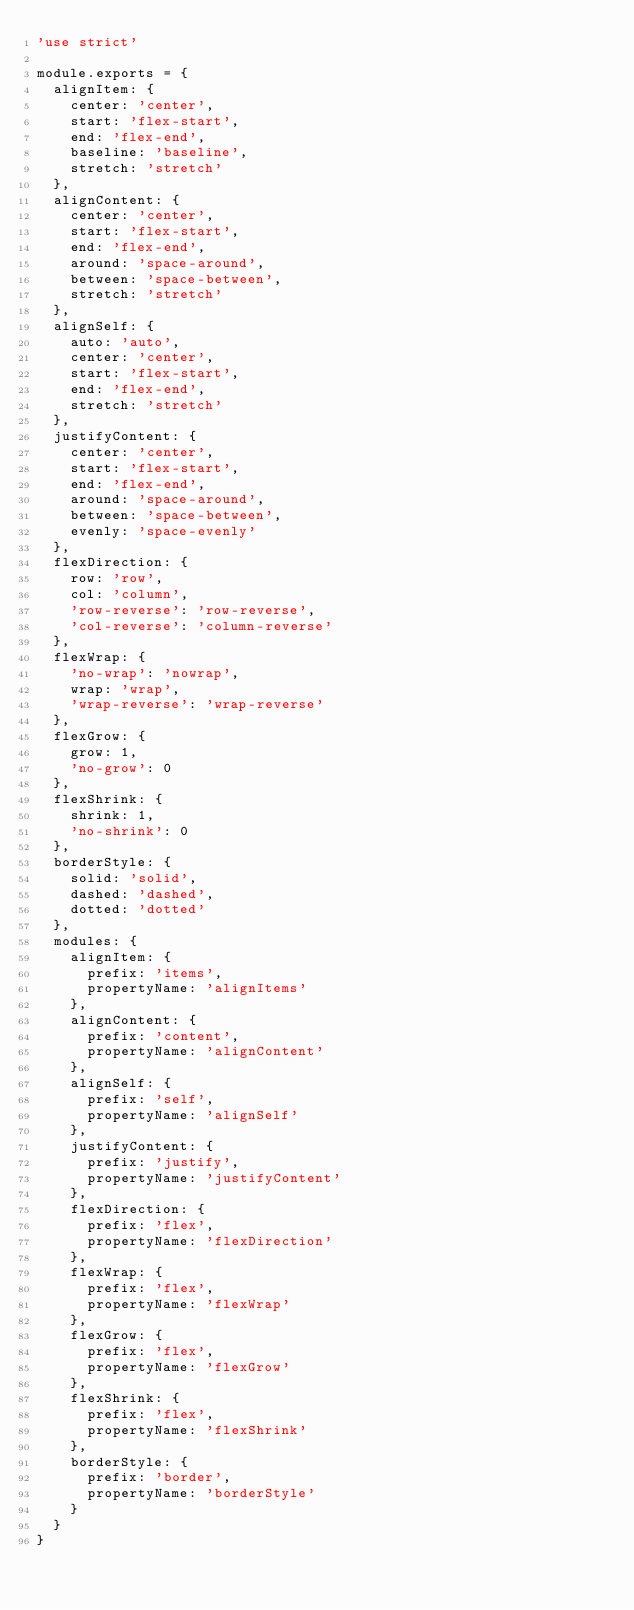<code> <loc_0><loc_0><loc_500><loc_500><_JavaScript_>'use strict'

module.exports = {
  alignItem: {
    center: 'center',
    start: 'flex-start',
    end: 'flex-end',
    baseline: 'baseline',
    stretch: 'stretch'
  },
  alignContent: {
    center: 'center',
    start: 'flex-start',
    end: 'flex-end',
    around: 'space-around',
    between: 'space-between',
    stretch: 'stretch'
  },
  alignSelf: {
    auto: 'auto',
    center: 'center',
    start: 'flex-start',
    end: 'flex-end',
    stretch: 'stretch'
  },
  justifyContent: {
    center: 'center',
    start: 'flex-start',
    end: 'flex-end',
    around: 'space-around',
    between: 'space-between',
    evenly: 'space-evenly'
  },
  flexDirection: {
    row: 'row',
    col: 'column',
    'row-reverse': 'row-reverse',
    'col-reverse': 'column-reverse'
  },
  flexWrap: {
    'no-wrap': 'nowrap',
    wrap: 'wrap',
    'wrap-reverse': 'wrap-reverse'
  },
  flexGrow: {
    grow: 1,
    'no-grow': 0
  },
  flexShrink: {
    shrink: 1,
    'no-shrink': 0
  },
  borderStyle: {
    solid: 'solid',
    dashed: 'dashed',
    dotted: 'dotted'
  },
  modules: {
    alignItem: {
      prefix: 'items',
      propertyName: 'alignItems'
    },
    alignContent: {
      prefix: 'content',
      propertyName: 'alignContent'
    },
    alignSelf: {
      prefix: 'self',
      propertyName: 'alignSelf'
    },
    justifyContent: {
      prefix: 'justify',
      propertyName: 'justifyContent'
    },
    flexDirection: {
      prefix: 'flex',
      propertyName: 'flexDirection'
    },
    flexWrap: {
      prefix: 'flex',
      propertyName: 'flexWrap'
    },
    flexGrow: {
      prefix: 'flex',
      propertyName: 'flexGrow'
    },
    flexShrink: {
      prefix: 'flex',
      propertyName: 'flexShrink'
    },
    borderStyle: {
      prefix: 'border',
      propertyName: 'borderStyle'
    }
  }
}
</code> 